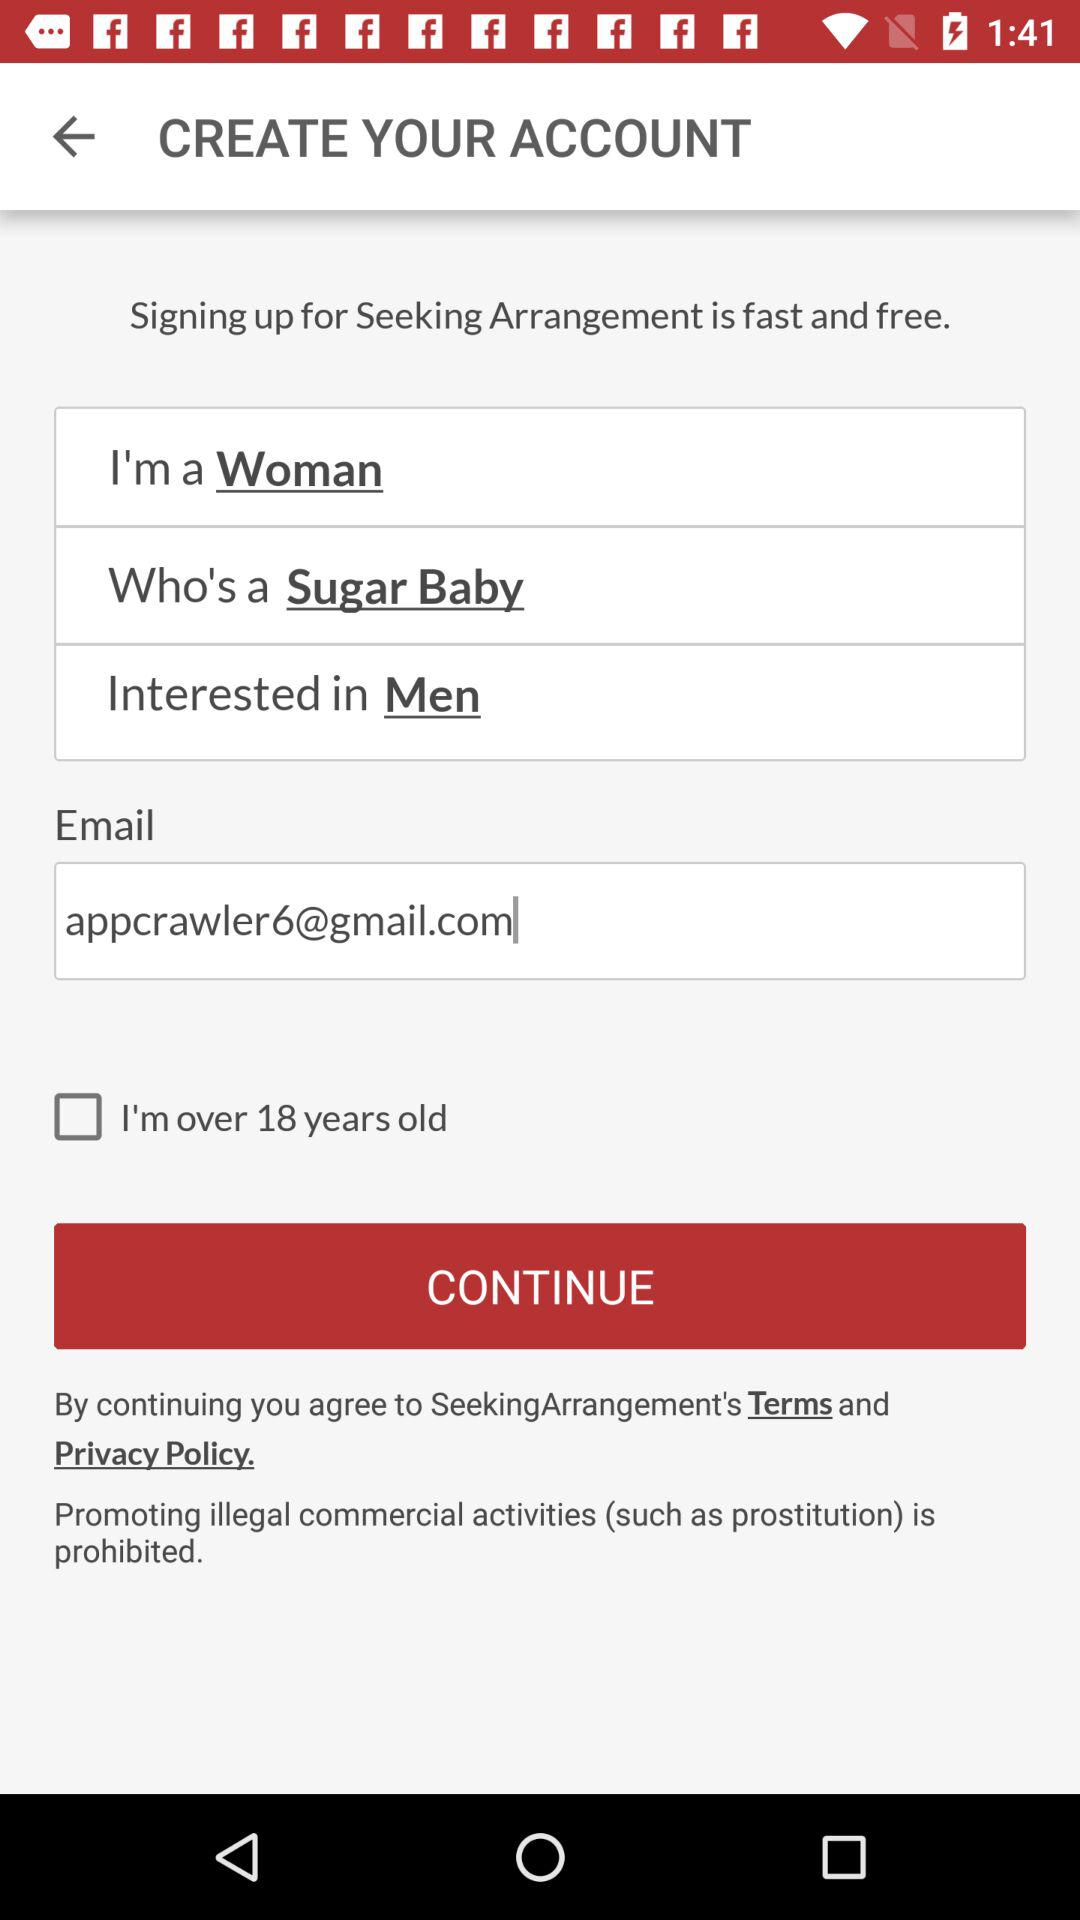How many input fields are there for gender?
Answer the question using a single word or phrase. 2 